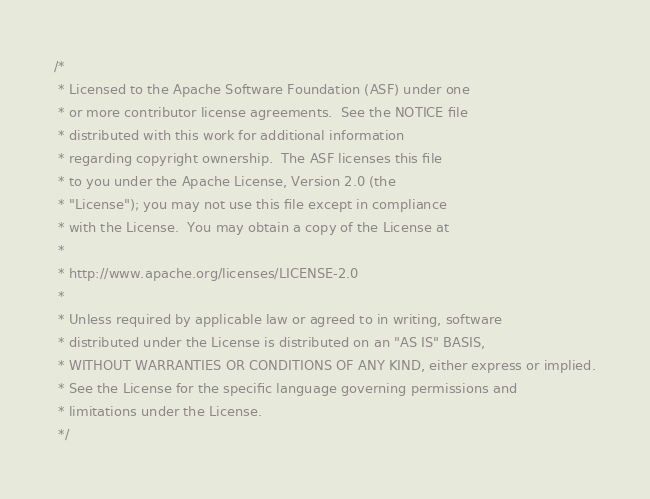Convert code to text. <code><loc_0><loc_0><loc_500><loc_500><_Java_>/*
 * Licensed to the Apache Software Foundation (ASF) under one
 * or more contributor license agreements.  See the NOTICE file
 * distributed with this work for additional information
 * regarding copyright ownership.  The ASF licenses this file
 * to you under the Apache License, Version 2.0 (the
 * "License"); you may not use this file except in compliance
 * with the License.  You may obtain a copy of the License at
 *
 * http://www.apache.org/licenses/LICENSE-2.0
 *
 * Unless required by applicable law or agreed to in writing, software
 * distributed under the License is distributed on an "AS IS" BASIS,
 * WITHOUT WARRANTIES OR CONDITIONS OF ANY KIND, either express or implied.
 * See the License for the specific language governing permissions and
 * limitations under the License.
 */</code> 